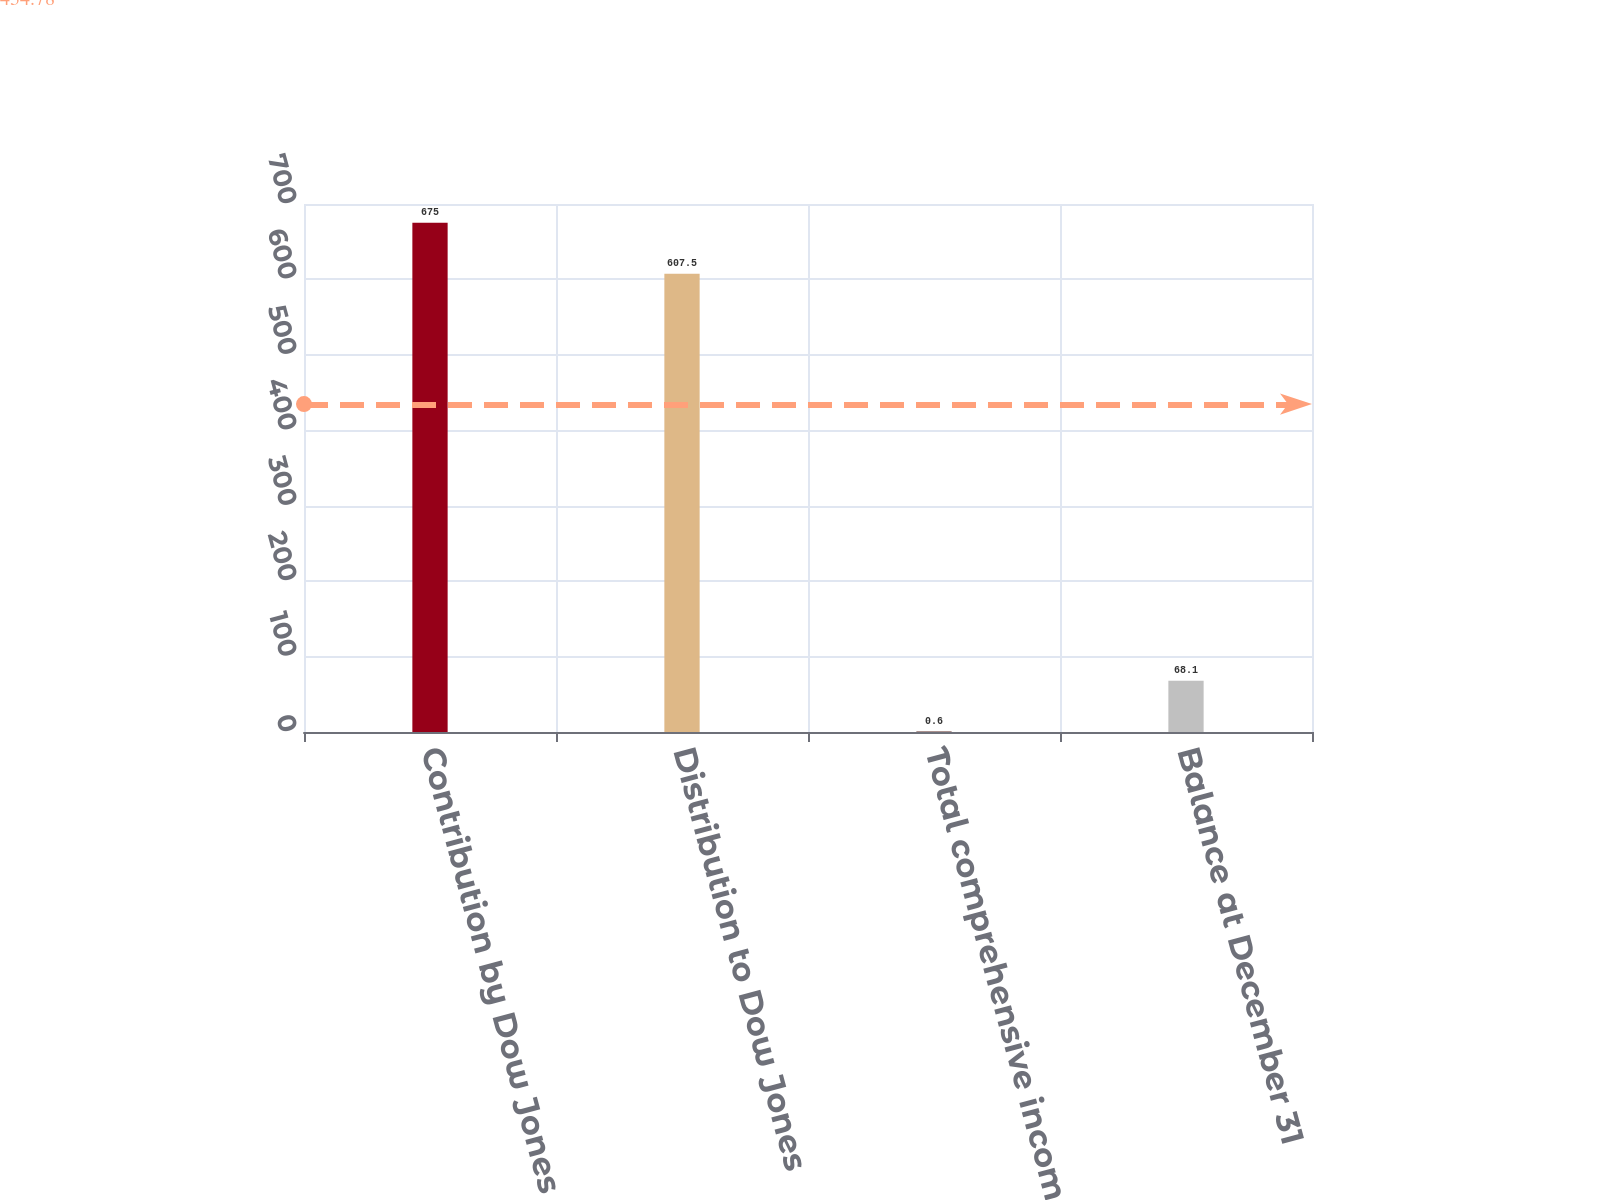Convert chart to OTSL. <chart><loc_0><loc_0><loc_500><loc_500><bar_chart><fcel>Contribution by Dow Jones<fcel>Distribution to Dow Jones<fcel>Total comprehensive income<fcel>Balance at December 31<nl><fcel>675<fcel>607.5<fcel>0.6<fcel>68.1<nl></chart> 